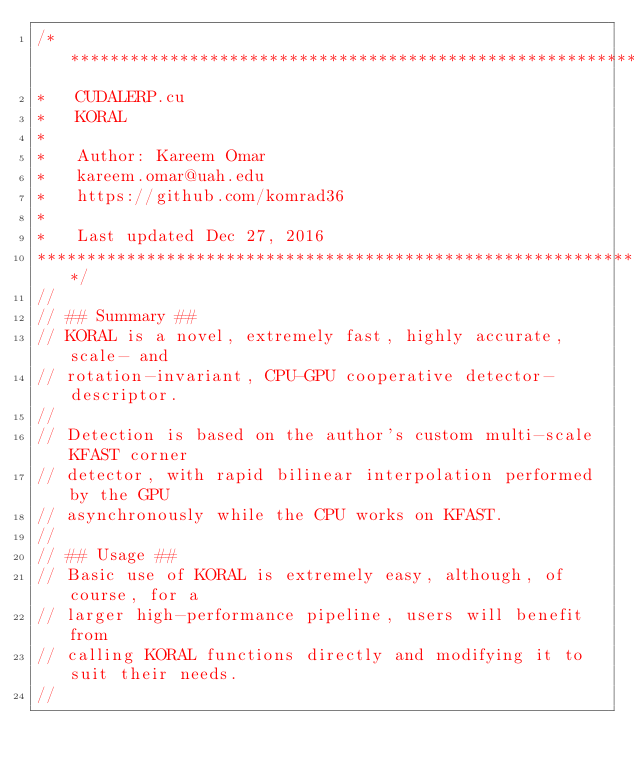<code> <loc_0><loc_0><loc_500><loc_500><_Cuda_>/*******************************************************************
*   CUDALERP.cu
*   KORAL
*
*	Author: Kareem Omar
*	kareem.omar@uah.edu
*	https://github.com/komrad36
*
*	Last updated Dec 27, 2016
*******************************************************************/
//
// ## Summary ##
// KORAL is a novel, extremely fast, highly accurate, scale- and
// rotation-invariant, CPU-GPU cooperative detector-descriptor.
//
// Detection is based on the author's custom multi-scale KFAST corner
// detector, with rapid bilinear interpolation performed by the GPU
// asynchronously while the CPU works on KFAST.
//
// ## Usage ##
// Basic use of KORAL is extremely easy, although, of course, for a
// larger high-performance pipeline, users will benefit from
// calling KORAL functions directly and modifying it to suit their needs.
//</code> 